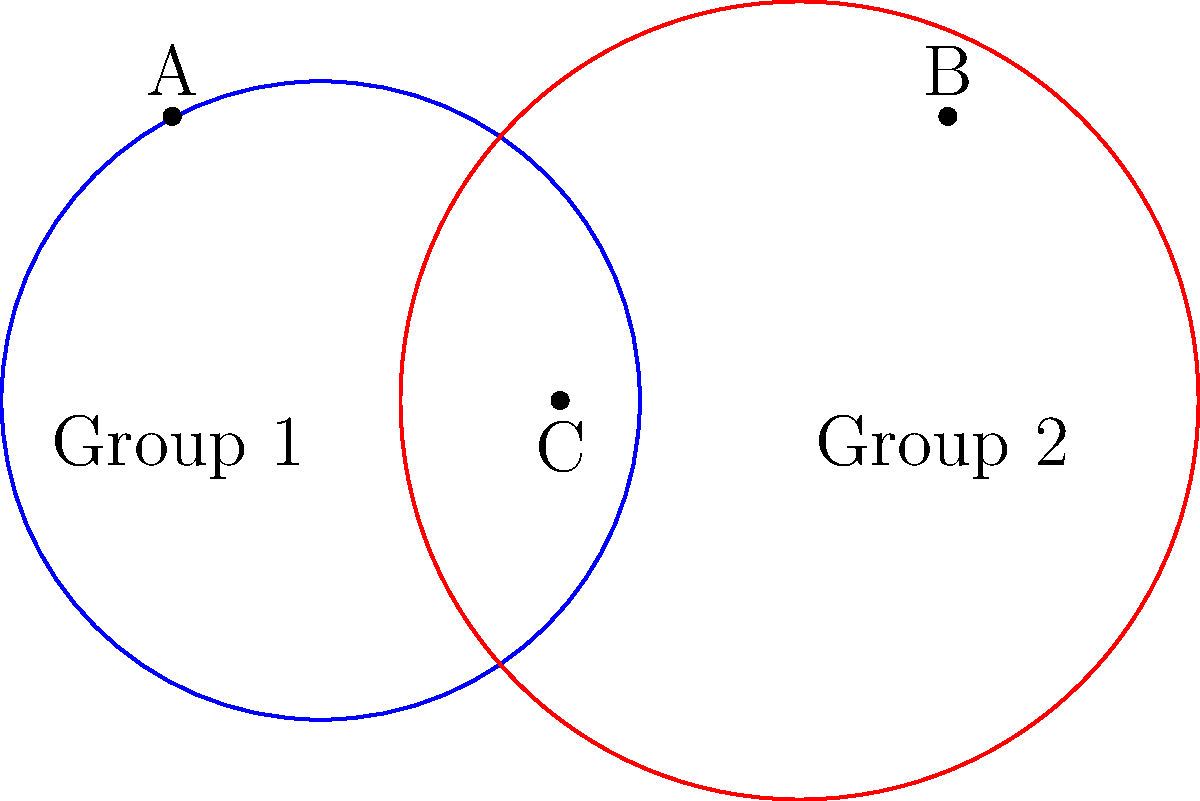As part of implementing diversity policies, you've set up two circular training zones for different employee groups in your factory. The first zone (blue) has a radius of 2 units, while the second zone (red) has a radius of 2.5 units. The centers of these zones are 3 units apart. Calculate the area of the overlapping region where both groups can interact. Round your answer to two decimal places. Let's approach this step-by-step:

1) First, we need to find the distance between the points where the circles intersect. We can do this using the formula:

   $$d = 2\sqrt{\frac{(r_1^2 + r_2^2)}{2} + \frac{D^2}{4} - \frac{r_1^2r_2^2}{D^2}}$$

   Where $r_1 = 2$, $r_2 = 2.5$, and $D = 3$ (distance between centers)

2) Plugging in the values:

   $$d = 2\sqrt{\frac{(2^2 + 2.5^2)}{2} + \frac{3^2}{4} - \frac{2^2(2.5^2)}{3^2}} \approx 3.56$$

3) Now, we can find the area of the overlapping region using the formula:

   $$A = r_1^2 \arccos(\frac{D^2 + r_1^2 - r_2^2}{2Dr_1}) + r_2^2 \arccos(\frac{D^2 + r_2^2 - r_1^2}{2Dr_2}) - \frac{1}{2}\sqrt{(-D+r_1+r_2)(D+r_1-r_2)(D-r_1+r_2)(D+r_1+r_2)}$$

4) Substituting the values:

   $$A = 2^2 \arccos(\frac{3^2 + 2^2 - 2.5^2}{2(3)(2)}) + 2.5^2 \arccos(\frac{3^2 + 2.5^2 - 2^2}{2(3)(2.5)}) - \frac{1}{2}\sqrt{(-3+2+2.5)(3+2-2.5)(3-2+2.5)(3+2+2.5)}$$

5) Calculating this (you would use a calculator):

   $$A \approx 5.0548$$

6) Rounding to two decimal places:

   $$A \approx 5.05$$
Answer: 5.05 square units 